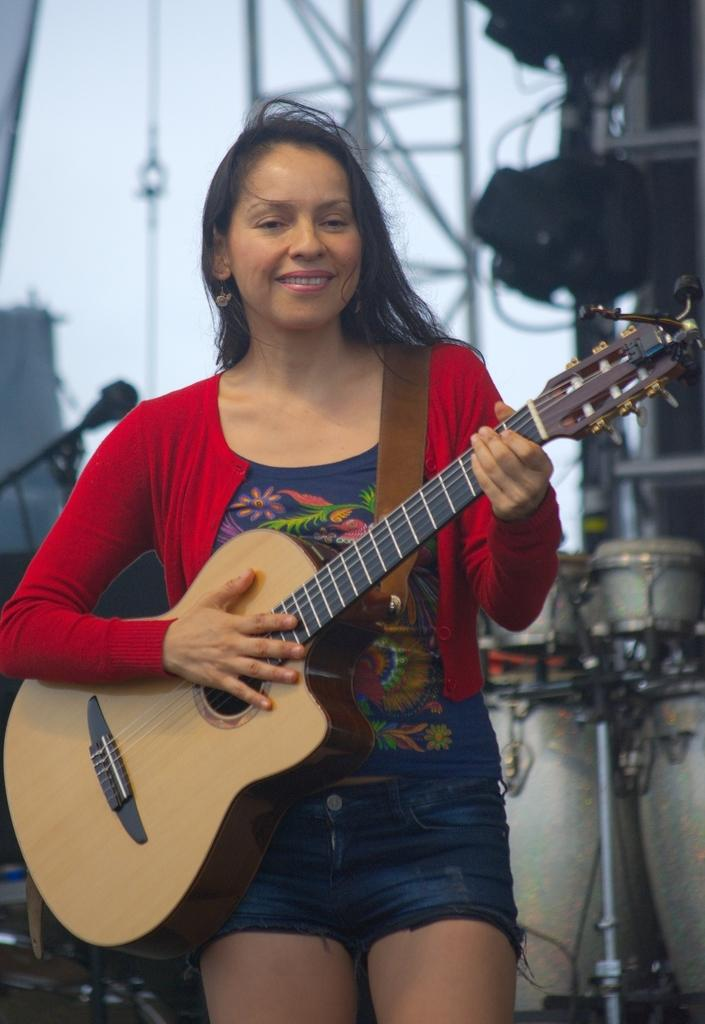Who is present in the image? There is a woman in the image. What is the woman doing in the image? The woman is standing in the image. What object is the woman holding in her hand? The woman is holding a guitar in her hand. What type of coach can be seen in the background of the image? There is no coach present in the image; it only features a woman standing and holding a guitar. 